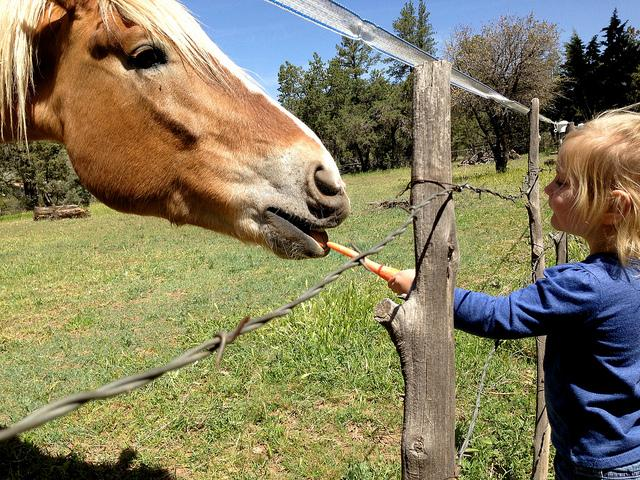What vegetable is toxic to horses?

Choices:
A) eggplant
B) carrot
C) tomatoes
D) beans tomatoes 